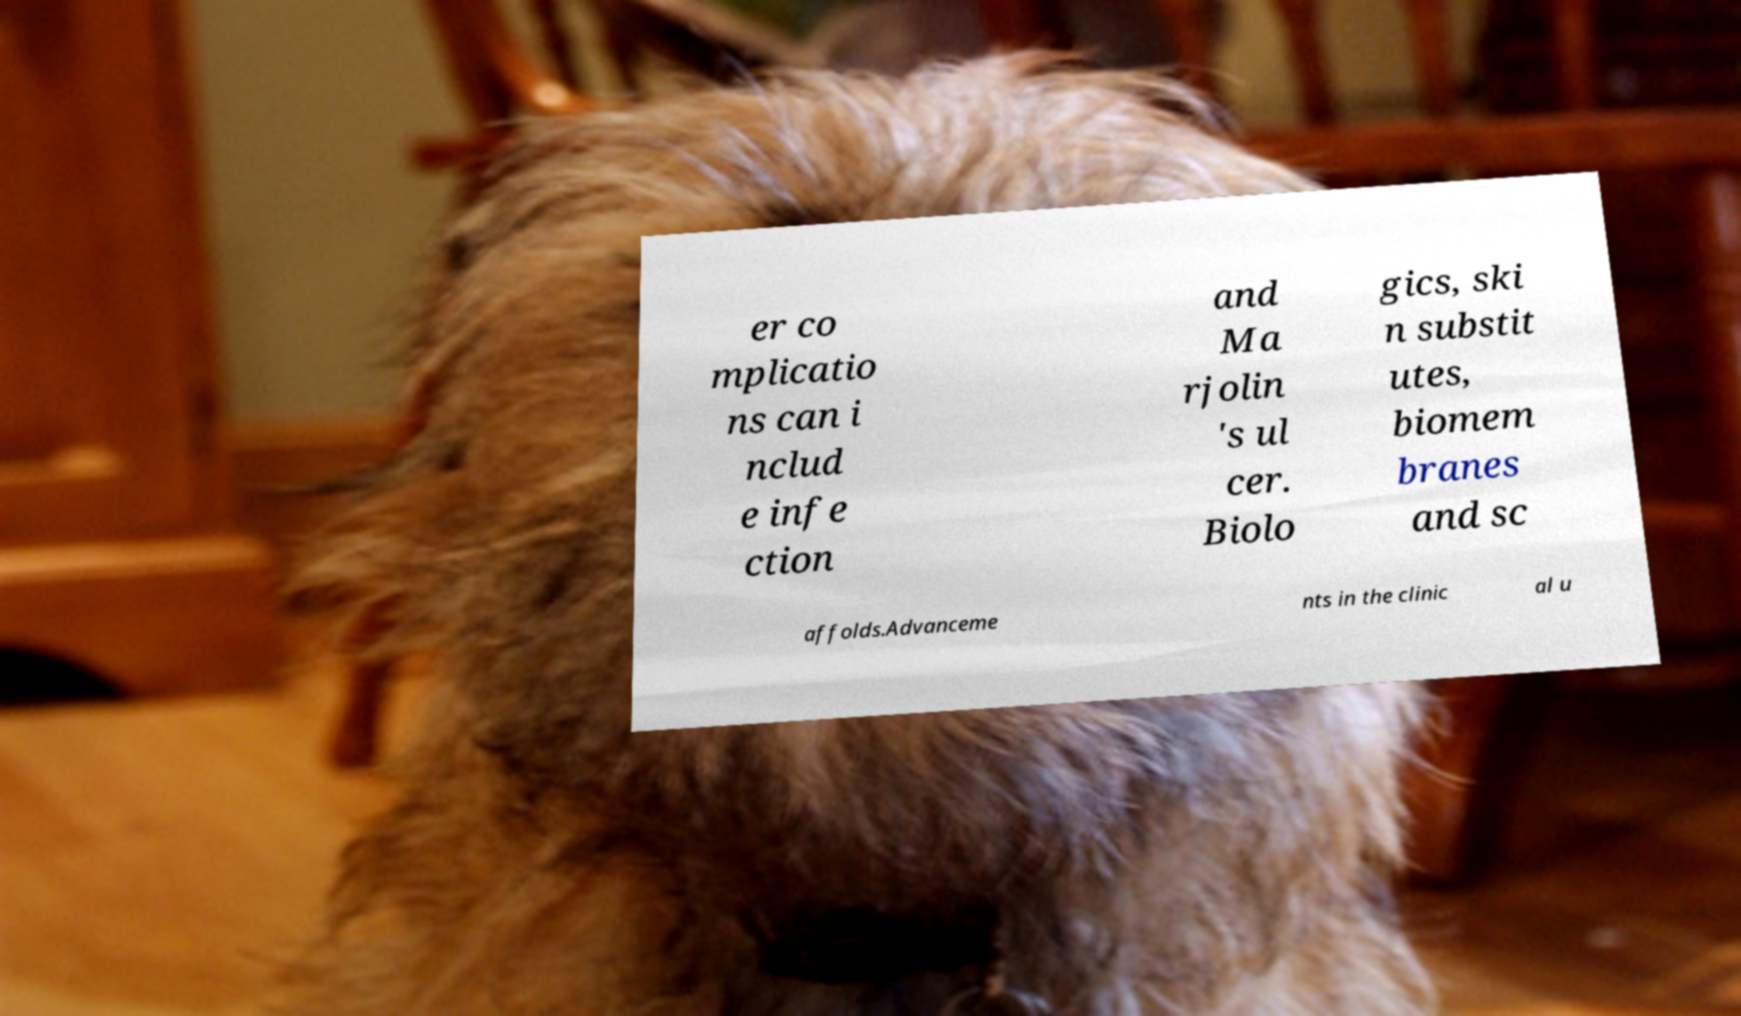There's text embedded in this image that I need extracted. Can you transcribe it verbatim? er co mplicatio ns can i nclud e infe ction and Ma rjolin 's ul cer. Biolo gics, ski n substit utes, biomem branes and sc affolds.Advanceme nts in the clinic al u 